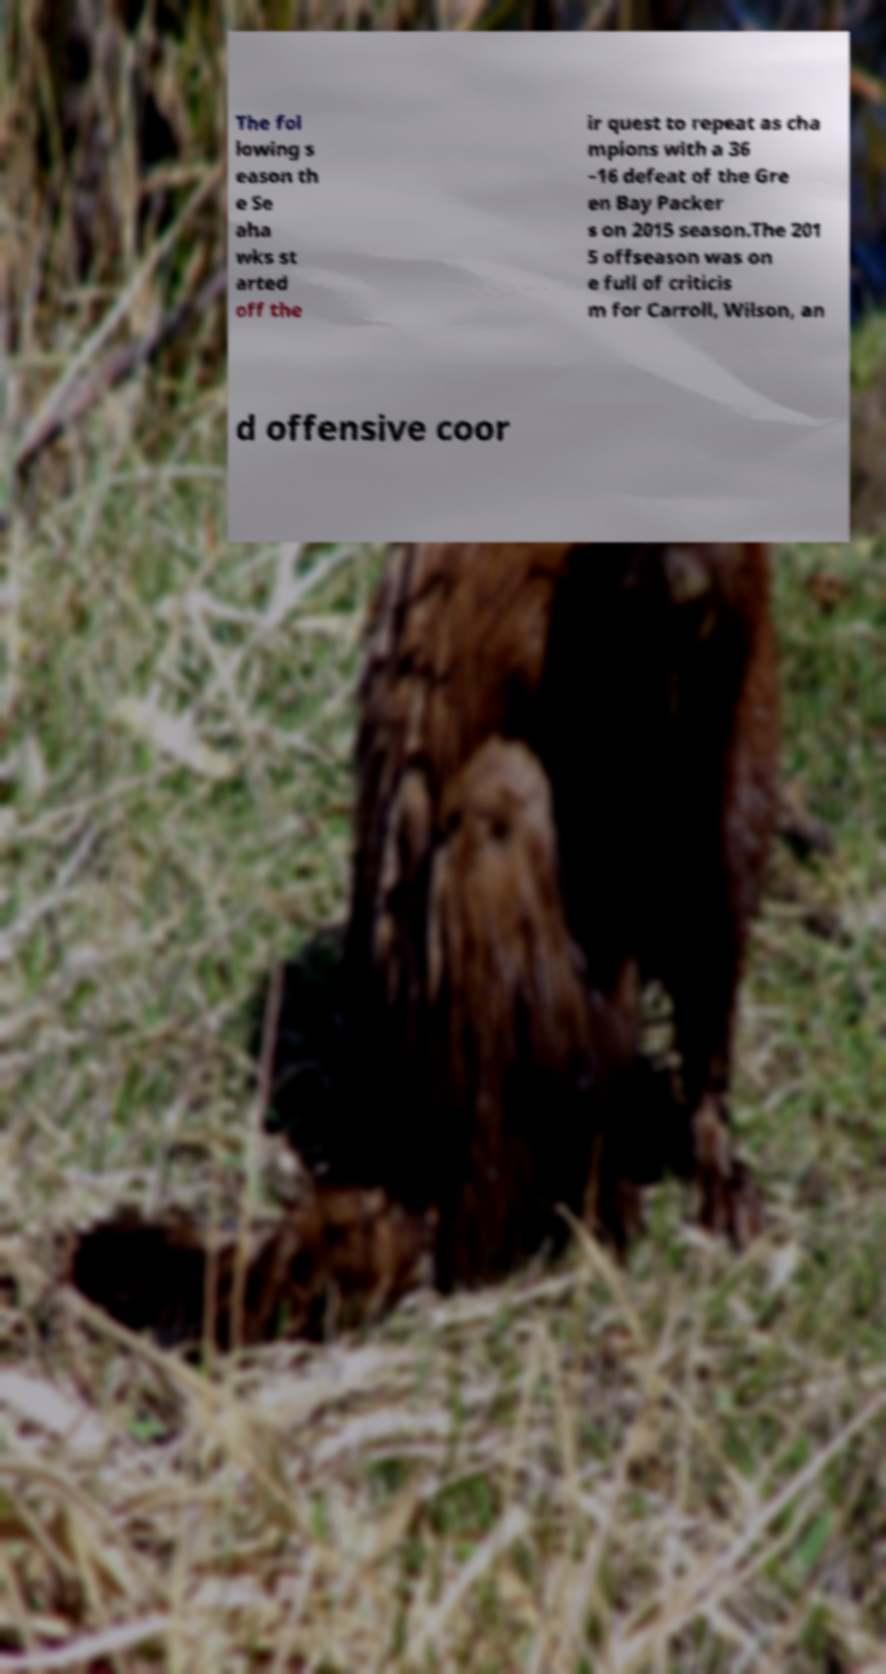Please identify and transcribe the text found in this image. The fol lowing s eason th e Se aha wks st arted off the ir quest to repeat as cha mpions with a 36 –16 defeat of the Gre en Bay Packer s on 2015 season.The 201 5 offseason was on e full of criticis m for Carroll, Wilson, an d offensive coor 